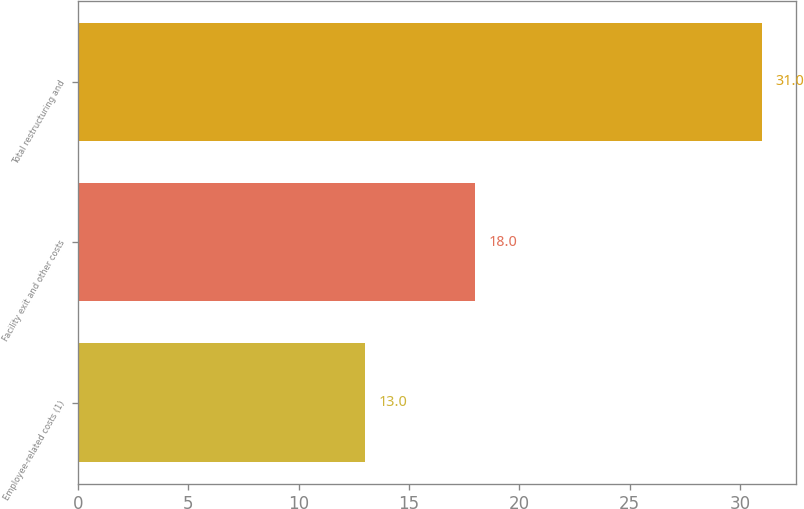Convert chart. <chart><loc_0><loc_0><loc_500><loc_500><bar_chart><fcel>Employee-related costs (1)<fcel>Facility exit and other costs<fcel>Total restructuring and<nl><fcel>13<fcel>18<fcel>31<nl></chart> 